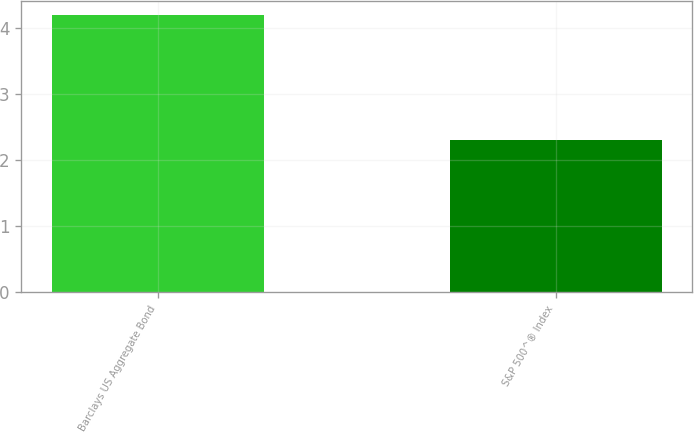<chart> <loc_0><loc_0><loc_500><loc_500><bar_chart><fcel>Barclays US Aggregate Bond<fcel>S&P 500^® Index<nl><fcel>4.2<fcel>2.3<nl></chart> 